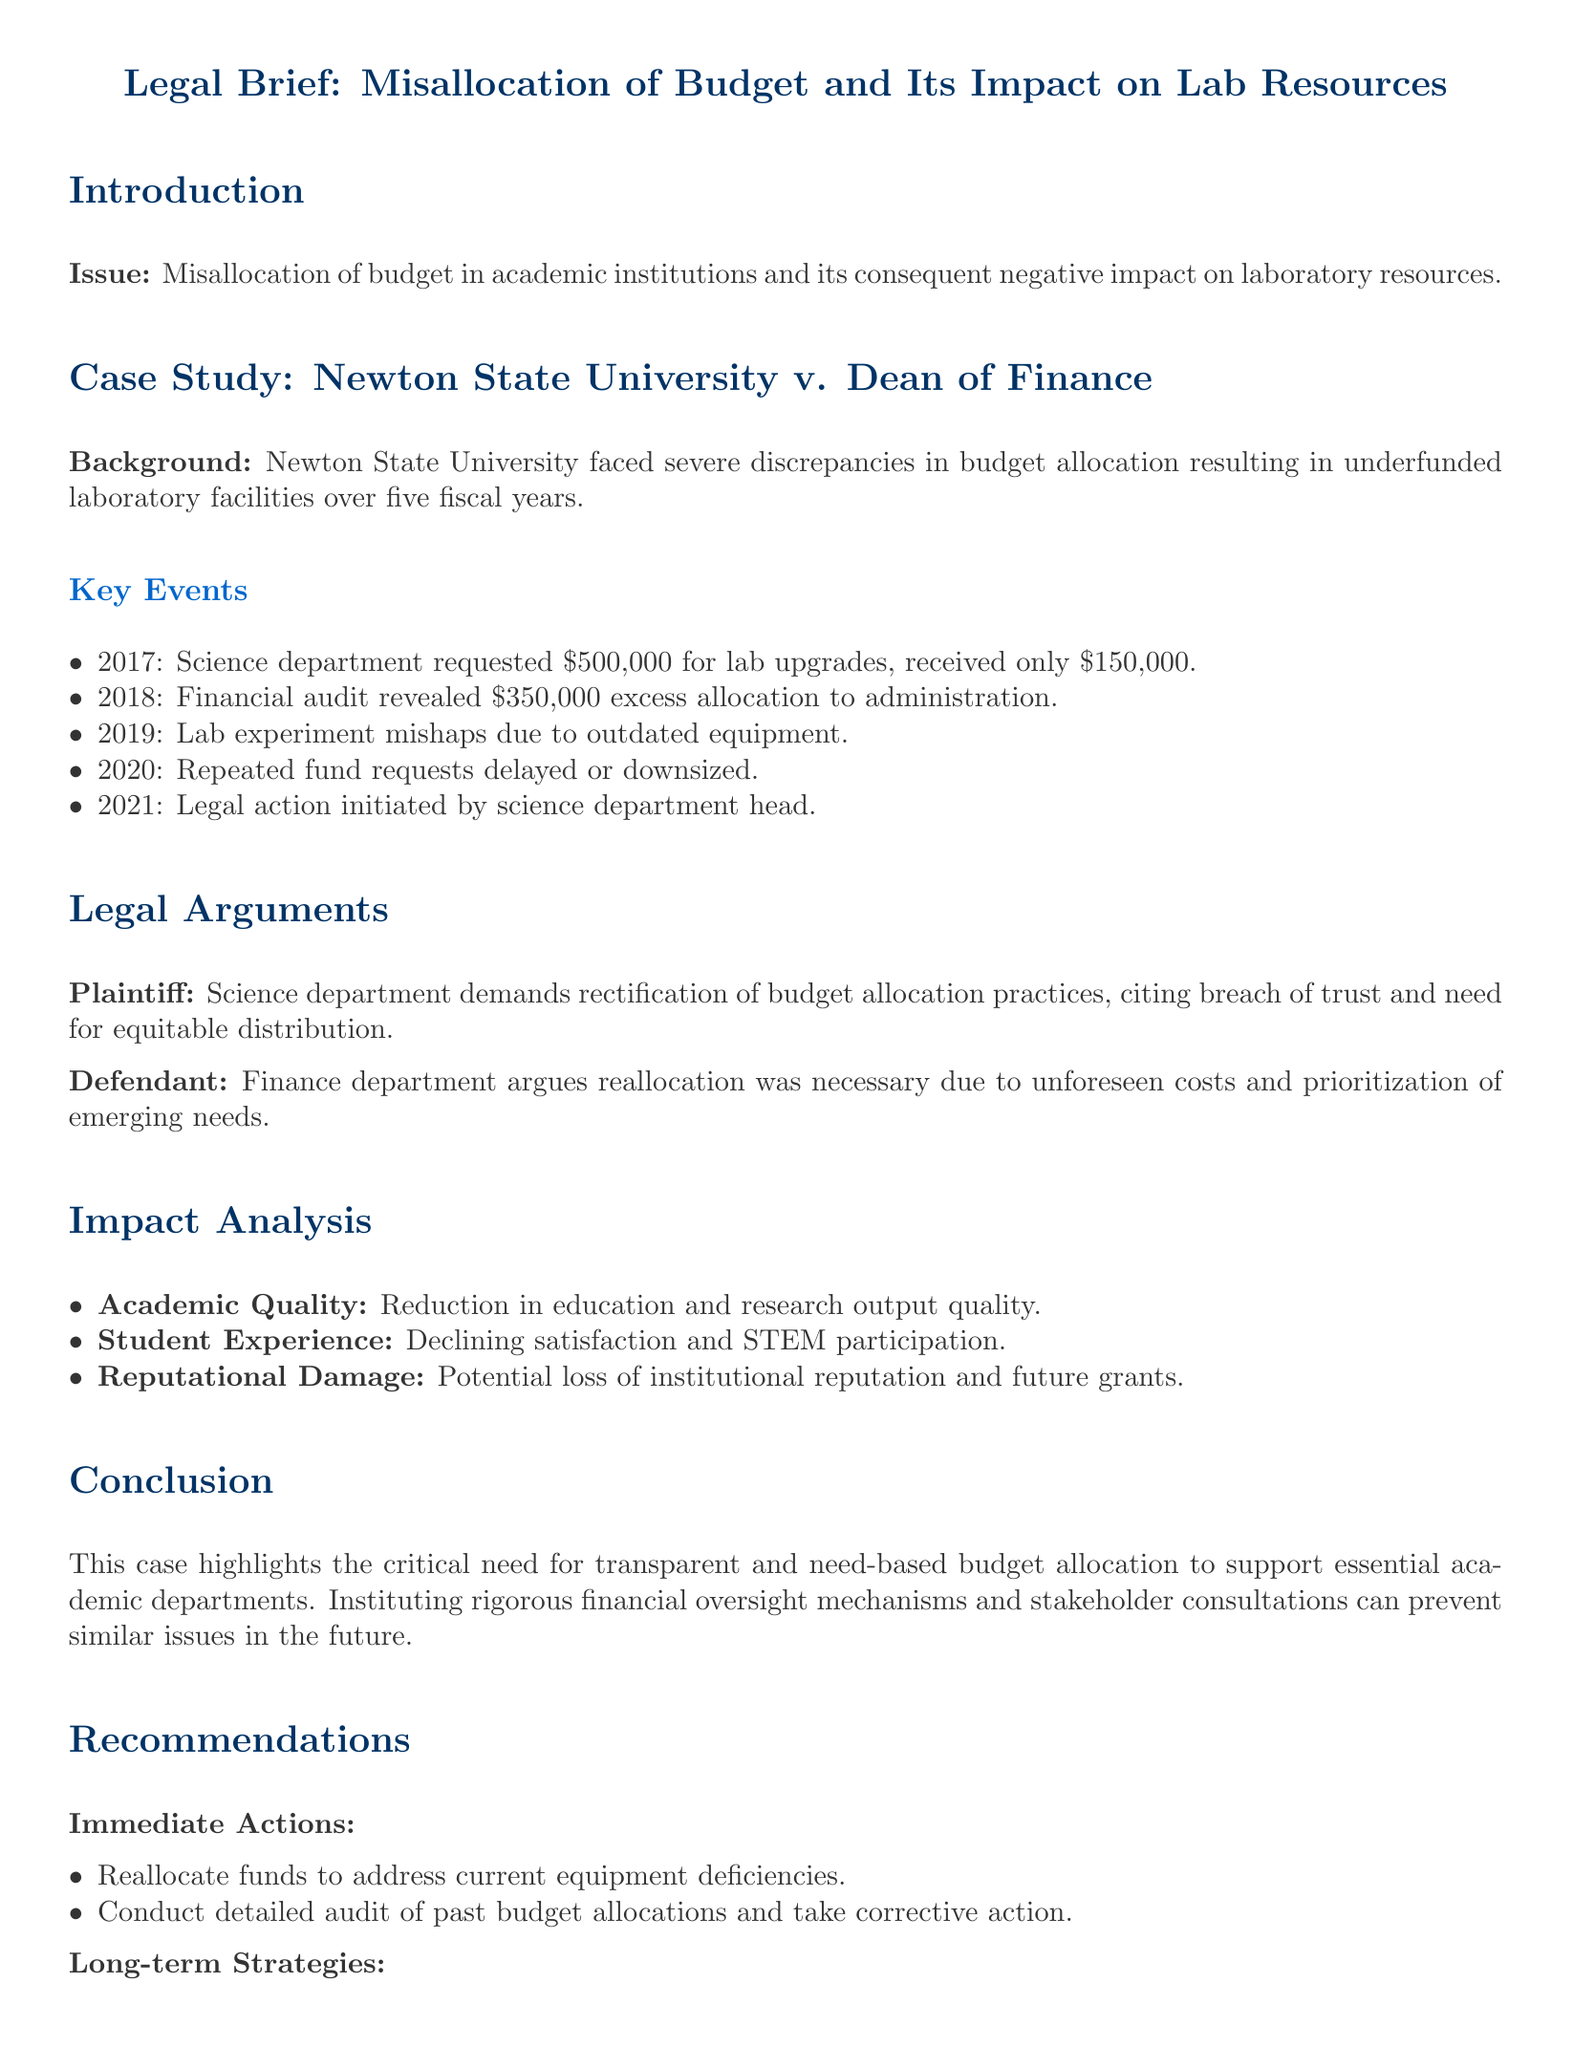What was the amount requested by the science department for lab upgrades in 2017? The science department requested $500,000 for lab upgrades in 2017.
Answer: $500,000 What year did the legal action initiated by the science department head take place? The legal action was initiated in 2021 by the science department head.
Answer: 2021 What was revealed by the financial audit in 2018? The financial audit revealed $350,000 excess allocation to administration in 2018.
Answer: $350,000 excess allocation Which department argues that reallocation was necessary due to unforeseen costs? The finance department argues that reallocation was necessary due to unforeseen costs.
Answer: Finance department What is one of the impacts of budget misallocation on academic quality? The impact noted is a reduction in education and research output quality.
Answer: Reduction in education and research output quality What immediate action is recommended to address current equipment deficiencies? One recommended immediate action is to reallocate funds to address current equipment deficiencies.
Answer: Reallocate funds What is a proposed long-term strategy mentioned in the case study? One proposed long-term strategy is to implement participatory budget planning involving department heads.
Answer: Implement participatory budget planning What year does the case study focus on regarding budget discrepancies? The case study focuses on budget discrepancies over five fiscal years starting from 2017.
Answer: Five fiscal years How did the budget allocation decisions affect student experience? The budget allocation decisions led to declining satisfaction and STEM participation among students.
Answer: Declining satisfaction and STEM participation 